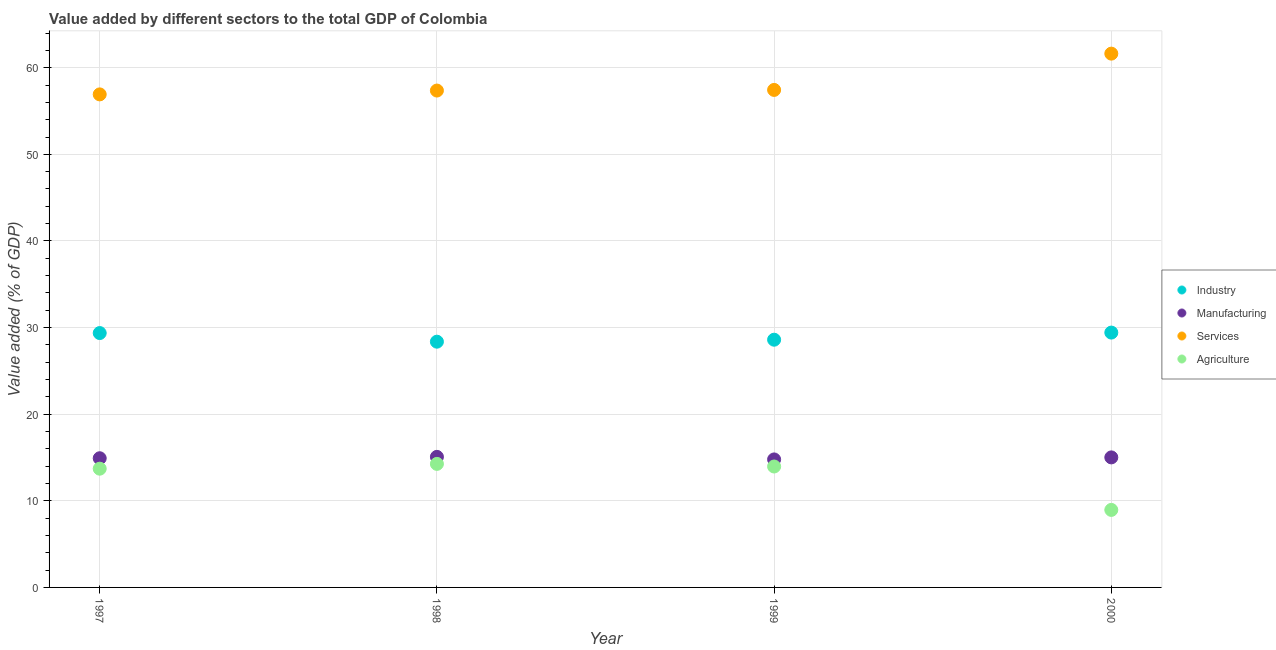Is the number of dotlines equal to the number of legend labels?
Keep it short and to the point. Yes. What is the value added by services sector in 1999?
Provide a succinct answer. 57.44. Across all years, what is the maximum value added by services sector?
Keep it short and to the point. 61.63. Across all years, what is the minimum value added by agricultural sector?
Your response must be concise. 8.95. What is the total value added by agricultural sector in the graph?
Your answer should be compact. 50.88. What is the difference between the value added by services sector in 1997 and that in 1998?
Provide a short and direct response. -0.44. What is the difference between the value added by services sector in 1997 and the value added by manufacturing sector in 2000?
Keep it short and to the point. 41.91. What is the average value added by services sector per year?
Offer a terse response. 58.34. In the year 1998, what is the difference between the value added by services sector and value added by agricultural sector?
Give a very brief answer. 43.1. In how many years, is the value added by manufacturing sector greater than 36 %?
Your answer should be compact. 0. What is the ratio of the value added by agricultural sector in 1998 to that in 1999?
Ensure brevity in your answer.  1.02. Is the value added by industrial sector in 1997 less than that in 2000?
Provide a short and direct response. Yes. Is the difference between the value added by services sector in 1998 and 1999 greater than the difference between the value added by manufacturing sector in 1998 and 1999?
Your answer should be very brief. No. What is the difference between the highest and the second highest value added by services sector?
Offer a very short reply. 4.19. What is the difference between the highest and the lowest value added by agricultural sector?
Offer a very short reply. 5.31. In how many years, is the value added by services sector greater than the average value added by services sector taken over all years?
Ensure brevity in your answer.  1. Is the sum of the value added by agricultural sector in 1997 and 1999 greater than the maximum value added by services sector across all years?
Ensure brevity in your answer.  No. Is it the case that in every year, the sum of the value added by agricultural sector and value added by industrial sector is greater than the sum of value added by services sector and value added by manufacturing sector?
Offer a very short reply. Yes. Does the value added by services sector monotonically increase over the years?
Your answer should be very brief. Yes. Is the value added by manufacturing sector strictly less than the value added by industrial sector over the years?
Keep it short and to the point. Yes. Does the graph contain any zero values?
Offer a terse response. No. Where does the legend appear in the graph?
Your answer should be very brief. Center right. How many legend labels are there?
Offer a very short reply. 4. What is the title of the graph?
Give a very brief answer. Value added by different sectors to the total GDP of Colombia. What is the label or title of the X-axis?
Your answer should be very brief. Year. What is the label or title of the Y-axis?
Keep it short and to the point. Value added (% of GDP). What is the Value added (% of GDP) in Industry in 1997?
Keep it short and to the point. 29.37. What is the Value added (% of GDP) in Manufacturing in 1997?
Keep it short and to the point. 14.92. What is the Value added (% of GDP) in Services in 1997?
Your response must be concise. 56.92. What is the Value added (% of GDP) in Agriculture in 1997?
Your answer should be very brief. 13.71. What is the Value added (% of GDP) of Industry in 1998?
Keep it short and to the point. 28.37. What is the Value added (% of GDP) of Manufacturing in 1998?
Provide a succinct answer. 15.07. What is the Value added (% of GDP) in Services in 1998?
Your response must be concise. 57.37. What is the Value added (% of GDP) in Agriculture in 1998?
Give a very brief answer. 14.26. What is the Value added (% of GDP) of Industry in 1999?
Provide a succinct answer. 28.6. What is the Value added (% of GDP) in Manufacturing in 1999?
Offer a terse response. 14.78. What is the Value added (% of GDP) in Services in 1999?
Give a very brief answer. 57.44. What is the Value added (% of GDP) of Agriculture in 1999?
Keep it short and to the point. 13.96. What is the Value added (% of GDP) of Industry in 2000?
Your response must be concise. 29.42. What is the Value added (% of GDP) of Manufacturing in 2000?
Offer a terse response. 15.01. What is the Value added (% of GDP) in Services in 2000?
Provide a short and direct response. 61.63. What is the Value added (% of GDP) of Agriculture in 2000?
Give a very brief answer. 8.95. Across all years, what is the maximum Value added (% of GDP) in Industry?
Ensure brevity in your answer.  29.42. Across all years, what is the maximum Value added (% of GDP) of Manufacturing?
Make the answer very short. 15.07. Across all years, what is the maximum Value added (% of GDP) of Services?
Offer a very short reply. 61.63. Across all years, what is the maximum Value added (% of GDP) in Agriculture?
Provide a short and direct response. 14.26. Across all years, what is the minimum Value added (% of GDP) of Industry?
Ensure brevity in your answer.  28.37. Across all years, what is the minimum Value added (% of GDP) in Manufacturing?
Ensure brevity in your answer.  14.78. Across all years, what is the minimum Value added (% of GDP) of Services?
Offer a terse response. 56.92. Across all years, what is the minimum Value added (% of GDP) of Agriculture?
Provide a short and direct response. 8.95. What is the total Value added (% of GDP) of Industry in the graph?
Your answer should be very brief. 115.76. What is the total Value added (% of GDP) in Manufacturing in the graph?
Your response must be concise. 59.78. What is the total Value added (% of GDP) in Services in the graph?
Offer a very short reply. 233.36. What is the total Value added (% of GDP) in Agriculture in the graph?
Your answer should be compact. 50.88. What is the difference between the Value added (% of GDP) in Industry in 1997 and that in 1998?
Offer a terse response. 1. What is the difference between the Value added (% of GDP) in Manufacturing in 1997 and that in 1998?
Offer a terse response. -0.16. What is the difference between the Value added (% of GDP) of Services in 1997 and that in 1998?
Give a very brief answer. -0.44. What is the difference between the Value added (% of GDP) in Agriculture in 1997 and that in 1998?
Offer a terse response. -0.55. What is the difference between the Value added (% of GDP) in Industry in 1997 and that in 1999?
Ensure brevity in your answer.  0.77. What is the difference between the Value added (% of GDP) in Manufacturing in 1997 and that in 1999?
Provide a succinct answer. 0.14. What is the difference between the Value added (% of GDP) in Services in 1997 and that in 1999?
Provide a short and direct response. -0.52. What is the difference between the Value added (% of GDP) in Agriculture in 1997 and that in 1999?
Ensure brevity in your answer.  -0.25. What is the difference between the Value added (% of GDP) in Industry in 1997 and that in 2000?
Offer a very short reply. -0.06. What is the difference between the Value added (% of GDP) in Manufacturing in 1997 and that in 2000?
Offer a terse response. -0.1. What is the difference between the Value added (% of GDP) of Services in 1997 and that in 2000?
Keep it short and to the point. -4.7. What is the difference between the Value added (% of GDP) in Agriculture in 1997 and that in 2000?
Provide a short and direct response. 4.76. What is the difference between the Value added (% of GDP) of Industry in 1998 and that in 1999?
Make the answer very short. -0.23. What is the difference between the Value added (% of GDP) in Manufacturing in 1998 and that in 1999?
Your answer should be very brief. 0.29. What is the difference between the Value added (% of GDP) of Services in 1998 and that in 1999?
Provide a succinct answer. -0.07. What is the difference between the Value added (% of GDP) in Agriculture in 1998 and that in 1999?
Your response must be concise. 0.3. What is the difference between the Value added (% of GDP) in Industry in 1998 and that in 2000?
Keep it short and to the point. -1.05. What is the difference between the Value added (% of GDP) of Manufacturing in 1998 and that in 2000?
Offer a terse response. 0.06. What is the difference between the Value added (% of GDP) in Services in 1998 and that in 2000?
Ensure brevity in your answer.  -4.26. What is the difference between the Value added (% of GDP) of Agriculture in 1998 and that in 2000?
Offer a terse response. 5.31. What is the difference between the Value added (% of GDP) of Industry in 1999 and that in 2000?
Your answer should be very brief. -0.82. What is the difference between the Value added (% of GDP) in Manufacturing in 1999 and that in 2000?
Provide a succinct answer. -0.23. What is the difference between the Value added (% of GDP) in Services in 1999 and that in 2000?
Your answer should be compact. -4.19. What is the difference between the Value added (% of GDP) of Agriculture in 1999 and that in 2000?
Your answer should be very brief. 5.01. What is the difference between the Value added (% of GDP) of Industry in 1997 and the Value added (% of GDP) of Manufacturing in 1998?
Offer a very short reply. 14.29. What is the difference between the Value added (% of GDP) in Industry in 1997 and the Value added (% of GDP) in Services in 1998?
Make the answer very short. -28. What is the difference between the Value added (% of GDP) of Industry in 1997 and the Value added (% of GDP) of Agriculture in 1998?
Your response must be concise. 15.1. What is the difference between the Value added (% of GDP) of Manufacturing in 1997 and the Value added (% of GDP) of Services in 1998?
Offer a very short reply. -42.45. What is the difference between the Value added (% of GDP) of Manufacturing in 1997 and the Value added (% of GDP) of Agriculture in 1998?
Ensure brevity in your answer.  0.65. What is the difference between the Value added (% of GDP) in Services in 1997 and the Value added (% of GDP) in Agriculture in 1998?
Offer a very short reply. 42.66. What is the difference between the Value added (% of GDP) in Industry in 1997 and the Value added (% of GDP) in Manufacturing in 1999?
Your response must be concise. 14.59. What is the difference between the Value added (% of GDP) in Industry in 1997 and the Value added (% of GDP) in Services in 1999?
Keep it short and to the point. -28.07. What is the difference between the Value added (% of GDP) of Industry in 1997 and the Value added (% of GDP) of Agriculture in 1999?
Provide a short and direct response. 15.41. What is the difference between the Value added (% of GDP) of Manufacturing in 1997 and the Value added (% of GDP) of Services in 1999?
Your answer should be compact. -42.52. What is the difference between the Value added (% of GDP) in Manufacturing in 1997 and the Value added (% of GDP) in Agriculture in 1999?
Provide a short and direct response. 0.95. What is the difference between the Value added (% of GDP) in Services in 1997 and the Value added (% of GDP) in Agriculture in 1999?
Ensure brevity in your answer.  42.96. What is the difference between the Value added (% of GDP) in Industry in 1997 and the Value added (% of GDP) in Manufacturing in 2000?
Provide a short and direct response. 14.35. What is the difference between the Value added (% of GDP) in Industry in 1997 and the Value added (% of GDP) in Services in 2000?
Keep it short and to the point. -32.26. What is the difference between the Value added (% of GDP) of Industry in 1997 and the Value added (% of GDP) of Agriculture in 2000?
Your response must be concise. 20.42. What is the difference between the Value added (% of GDP) in Manufacturing in 1997 and the Value added (% of GDP) in Services in 2000?
Your answer should be compact. -46.71. What is the difference between the Value added (% of GDP) of Manufacturing in 1997 and the Value added (% of GDP) of Agriculture in 2000?
Keep it short and to the point. 5.97. What is the difference between the Value added (% of GDP) in Services in 1997 and the Value added (% of GDP) in Agriculture in 2000?
Provide a succinct answer. 47.97. What is the difference between the Value added (% of GDP) in Industry in 1998 and the Value added (% of GDP) in Manufacturing in 1999?
Your answer should be compact. 13.59. What is the difference between the Value added (% of GDP) in Industry in 1998 and the Value added (% of GDP) in Services in 1999?
Make the answer very short. -29.07. What is the difference between the Value added (% of GDP) of Industry in 1998 and the Value added (% of GDP) of Agriculture in 1999?
Keep it short and to the point. 14.41. What is the difference between the Value added (% of GDP) in Manufacturing in 1998 and the Value added (% of GDP) in Services in 1999?
Provide a short and direct response. -42.37. What is the difference between the Value added (% of GDP) in Manufacturing in 1998 and the Value added (% of GDP) in Agriculture in 1999?
Make the answer very short. 1.11. What is the difference between the Value added (% of GDP) in Services in 1998 and the Value added (% of GDP) in Agriculture in 1999?
Offer a very short reply. 43.4. What is the difference between the Value added (% of GDP) in Industry in 1998 and the Value added (% of GDP) in Manufacturing in 2000?
Your response must be concise. 13.36. What is the difference between the Value added (% of GDP) in Industry in 1998 and the Value added (% of GDP) in Services in 2000?
Your answer should be very brief. -33.26. What is the difference between the Value added (% of GDP) of Industry in 1998 and the Value added (% of GDP) of Agriculture in 2000?
Give a very brief answer. 19.42. What is the difference between the Value added (% of GDP) in Manufacturing in 1998 and the Value added (% of GDP) in Services in 2000?
Make the answer very short. -46.55. What is the difference between the Value added (% of GDP) in Manufacturing in 1998 and the Value added (% of GDP) in Agriculture in 2000?
Your response must be concise. 6.12. What is the difference between the Value added (% of GDP) in Services in 1998 and the Value added (% of GDP) in Agriculture in 2000?
Offer a very short reply. 48.42. What is the difference between the Value added (% of GDP) of Industry in 1999 and the Value added (% of GDP) of Manufacturing in 2000?
Make the answer very short. 13.59. What is the difference between the Value added (% of GDP) of Industry in 1999 and the Value added (% of GDP) of Services in 2000?
Ensure brevity in your answer.  -33.03. What is the difference between the Value added (% of GDP) of Industry in 1999 and the Value added (% of GDP) of Agriculture in 2000?
Provide a succinct answer. 19.65. What is the difference between the Value added (% of GDP) in Manufacturing in 1999 and the Value added (% of GDP) in Services in 2000?
Provide a short and direct response. -46.85. What is the difference between the Value added (% of GDP) of Manufacturing in 1999 and the Value added (% of GDP) of Agriculture in 2000?
Make the answer very short. 5.83. What is the difference between the Value added (% of GDP) in Services in 1999 and the Value added (% of GDP) in Agriculture in 2000?
Your response must be concise. 48.49. What is the average Value added (% of GDP) of Industry per year?
Give a very brief answer. 28.94. What is the average Value added (% of GDP) of Manufacturing per year?
Your response must be concise. 14.94. What is the average Value added (% of GDP) of Services per year?
Your answer should be compact. 58.34. What is the average Value added (% of GDP) of Agriculture per year?
Provide a succinct answer. 12.72. In the year 1997, what is the difference between the Value added (% of GDP) of Industry and Value added (% of GDP) of Manufacturing?
Offer a terse response. 14.45. In the year 1997, what is the difference between the Value added (% of GDP) in Industry and Value added (% of GDP) in Services?
Your response must be concise. -27.56. In the year 1997, what is the difference between the Value added (% of GDP) in Industry and Value added (% of GDP) in Agriculture?
Provide a succinct answer. 15.66. In the year 1997, what is the difference between the Value added (% of GDP) in Manufacturing and Value added (% of GDP) in Services?
Offer a very short reply. -42.01. In the year 1997, what is the difference between the Value added (% of GDP) of Manufacturing and Value added (% of GDP) of Agriculture?
Keep it short and to the point. 1.21. In the year 1997, what is the difference between the Value added (% of GDP) of Services and Value added (% of GDP) of Agriculture?
Keep it short and to the point. 43.21. In the year 1998, what is the difference between the Value added (% of GDP) of Industry and Value added (% of GDP) of Manufacturing?
Offer a very short reply. 13.3. In the year 1998, what is the difference between the Value added (% of GDP) of Industry and Value added (% of GDP) of Services?
Your response must be concise. -28.99. In the year 1998, what is the difference between the Value added (% of GDP) of Industry and Value added (% of GDP) of Agriculture?
Make the answer very short. 14.11. In the year 1998, what is the difference between the Value added (% of GDP) in Manufacturing and Value added (% of GDP) in Services?
Keep it short and to the point. -42.29. In the year 1998, what is the difference between the Value added (% of GDP) of Manufacturing and Value added (% of GDP) of Agriculture?
Keep it short and to the point. 0.81. In the year 1998, what is the difference between the Value added (% of GDP) of Services and Value added (% of GDP) of Agriculture?
Provide a short and direct response. 43.1. In the year 1999, what is the difference between the Value added (% of GDP) of Industry and Value added (% of GDP) of Manufacturing?
Your answer should be compact. 13.82. In the year 1999, what is the difference between the Value added (% of GDP) of Industry and Value added (% of GDP) of Services?
Offer a very short reply. -28.84. In the year 1999, what is the difference between the Value added (% of GDP) of Industry and Value added (% of GDP) of Agriculture?
Offer a terse response. 14.64. In the year 1999, what is the difference between the Value added (% of GDP) in Manufacturing and Value added (% of GDP) in Services?
Your answer should be very brief. -42.66. In the year 1999, what is the difference between the Value added (% of GDP) of Manufacturing and Value added (% of GDP) of Agriculture?
Your response must be concise. 0.82. In the year 1999, what is the difference between the Value added (% of GDP) of Services and Value added (% of GDP) of Agriculture?
Provide a short and direct response. 43.48. In the year 2000, what is the difference between the Value added (% of GDP) of Industry and Value added (% of GDP) of Manufacturing?
Your answer should be compact. 14.41. In the year 2000, what is the difference between the Value added (% of GDP) of Industry and Value added (% of GDP) of Services?
Keep it short and to the point. -32.21. In the year 2000, what is the difference between the Value added (% of GDP) of Industry and Value added (% of GDP) of Agriculture?
Offer a very short reply. 20.47. In the year 2000, what is the difference between the Value added (% of GDP) in Manufacturing and Value added (% of GDP) in Services?
Offer a very short reply. -46.62. In the year 2000, what is the difference between the Value added (% of GDP) in Manufacturing and Value added (% of GDP) in Agriculture?
Give a very brief answer. 6.06. In the year 2000, what is the difference between the Value added (% of GDP) of Services and Value added (% of GDP) of Agriculture?
Ensure brevity in your answer.  52.68. What is the ratio of the Value added (% of GDP) of Industry in 1997 to that in 1998?
Give a very brief answer. 1.04. What is the ratio of the Value added (% of GDP) in Services in 1997 to that in 1998?
Your answer should be compact. 0.99. What is the ratio of the Value added (% of GDP) of Agriculture in 1997 to that in 1998?
Provide a succinct answer. 0.96. What is the ratio of the Value added (% of GDP) of Industry in 1997 to that in 1999?
Ensure brevity in your answer.  1.03. What is the ratio of the Value added (% of GDP) in Manufacturing in 1997 to that in 1999?
Provide a short and direct response. 1.01. What is the ratio of the Value added (% of GDP) of Manufacturing in 1997 to that in 2000?
Ensure brevity in your answer.  0.99. What is the ratio of the Value added (% of GDP) in Services in 1997 to that in 2000?
Offer a very short reply. 0.92. What is the ratio of the Value added (% of GDP) in Agriculture in 1997 to that in 2000?
Make the answer very short. 1.53. What is the ratio of the Value added (% of GDP) in Industry in 1998 to that in 1999?
Offer a terse response. 0.99. What is the ratio of the Value added (% of GDP) in Manufacturing in 1998 to that in 1999?
Provide a succinct answer. 1.02. What is the ratio of the Value added (% of GDP) of Agriculture in 1998 to that in 1999?
Your answer should be compact. 1.02. What is the ratio of the Value added (% of GDP) in Industry in 1998 to that in 2000?
Offer a very short reply. 0.96. What is the ratio of the Value added (% of GDP) in Manufacturing in 1998 to that in 2000?
Keep it short and to the point. 1. What is the ratio of the Value added (% of GDP) in Services in 1998 to that in 2000?
Offer a very short reply. 0.93. What is the ratio of the Value added (% of GDP) of Agriculture in 1998 to that in 2000?
Make the answer very short. 1.59. What is the ratio of the Value added (% of GDP) of Industry in 1999 to that in 2000?
Keep it short and to the point. 0.97. What is the ratio of the Value added (% of GDP) in Manufacturing in 1999 to that in 2000?
Make the answer very short. 0.98. What is the ratio of the Value added (% of GDP) in Services in 1999 to that in 2000?
Your answer should be very brief. 0.93. What is the ratio of the Value added (% of GDP) in Agriculture in 1999 to that in 2000?
Give a very brief answer. 1.56. What is the difference between the highest and the second highest Value added (% of GDP) of Industry?
Offer a very short reply. 0.06. What is the difference between the highest and the second highest Value added (% of GDP) of Manufacturing?
Your answer should be compact. 0.06. What is the difference between the highest and the second highest Value added (% of GDP) in Services?
Provide a short and direct response. 4.19. What is the difference between the highest and the second highest Value added (% of GDP) of Agriculture?
Make the answer very short. 0.3. What is the difference between the highest and the lowest Value added (% of GDP) of Industry?
Your answer should be compact. 1.05. What is the difference between the highest and the lowest Value added (% of GDP) in Manufacturing?
Provide a succinct answer. 0.29. What is the difference between the highest and the lowest Value added (% of GDP) in Services?
Ensure brevity in your answer.  4.7. What is the difference between the highest and the lowest Value added (% of GDP) of Agriculture?
Give a very brief answer. 5.31. 